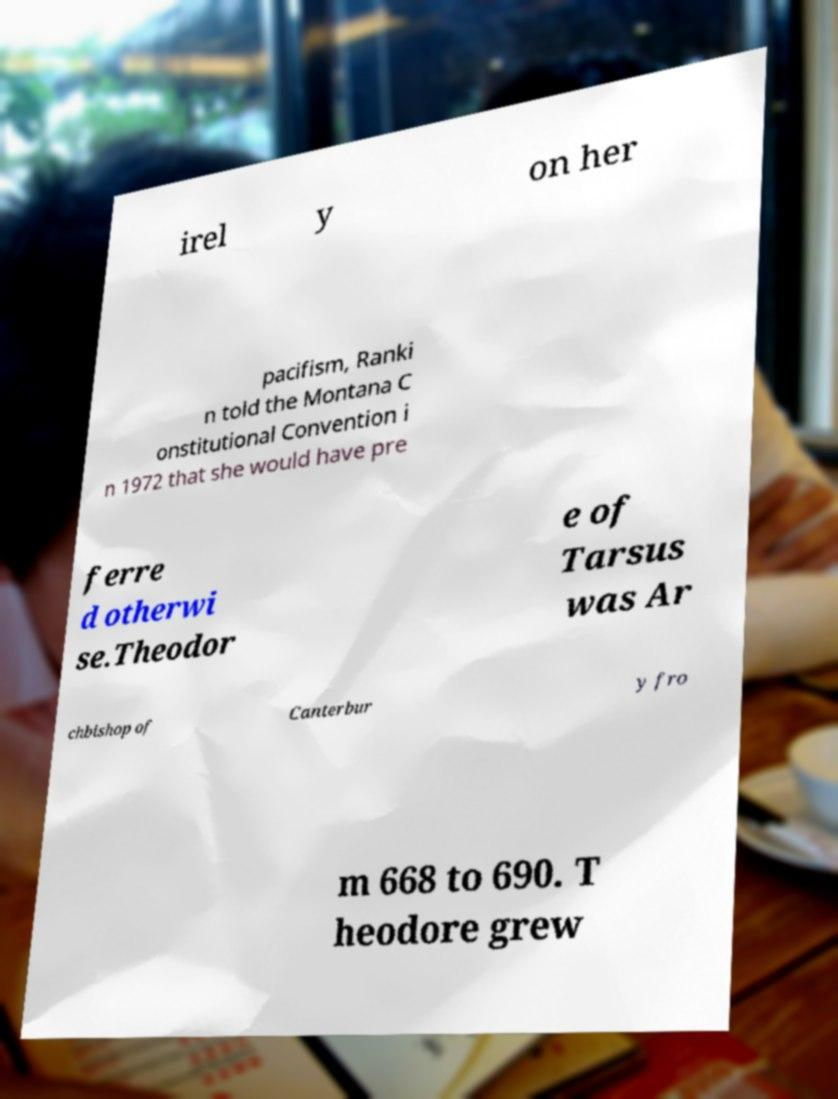Can you accurately transcribe the text from the provided image for me? irel y on her pacifism, Ranki n told the Montana C onstitutional Convention i n 1972 that she would have pre ferre d otherwi se.Theodor e of Tarsus was Ar chbishop of Canterbur y fro m 668 to 690. T heodore grew 